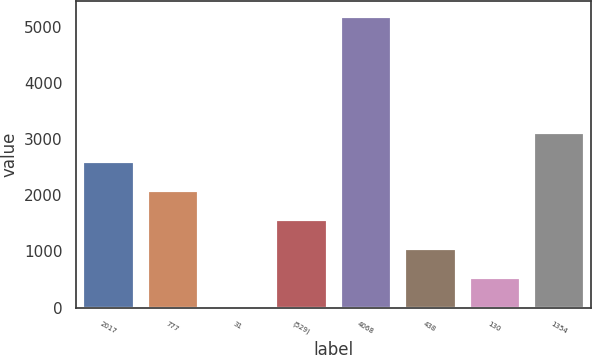<chart> <loc_0><loc_0><loc_500><loc_500><bar_chart><fcel>2017<fcel>777<fcel>31<fcel>(529)<fcel>4068<fcel>438<fcel>130<fcel>1354<nl><fcel>2616<fcel>2099<fcel>31<fcel>1582<fcel>5201<fcel>1065<fcel>548<fcel>3133<nl></chart> 